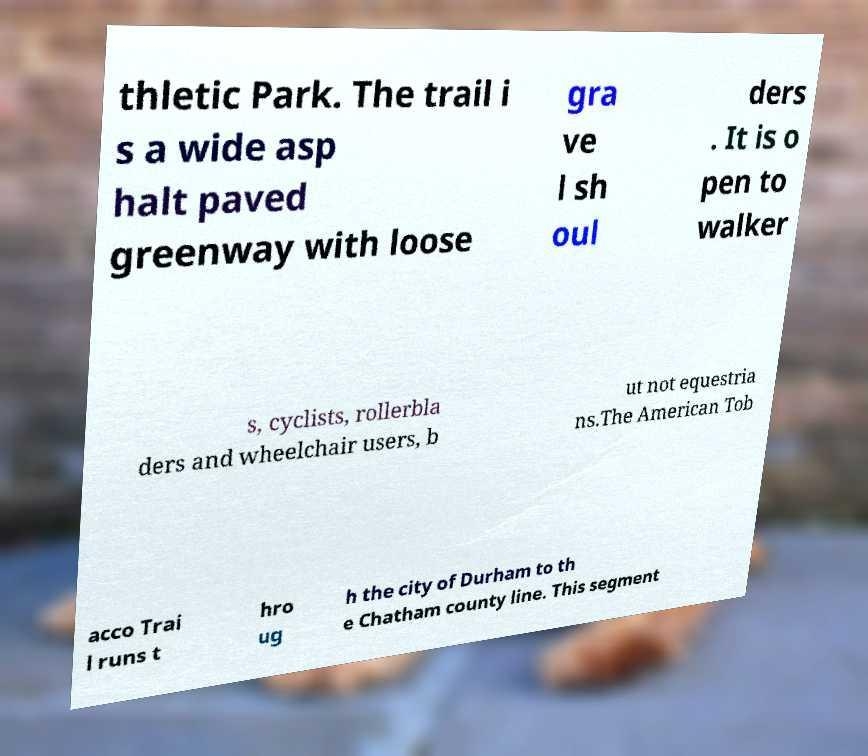Could you extract and type out the text from this image? thletic Park. The trail i s a wide asp halt paved greenway with loose gra ve l sh oul ders . It is o pen to walker s, cyclists, rollerbla ders and wheelchair users, b ut not equestria ns.The American Tob acco Trai l runs t hro ug h the city of Durham to th e Chatham county line. This segment 